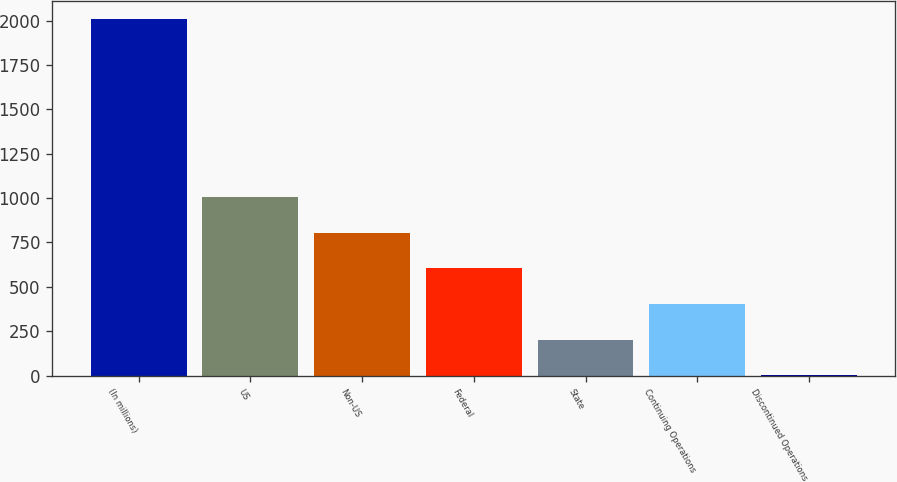<chart> <loc_0><loc_0><loc_500><loc_500><bar_chart><fcel>(In millions)<fcel>US<fcel>Non-US<fcel>Federal<fcel>State<fcel>Continuing Operations<fcel>Discontinued Operations<nl><fcel>2010<fcel>1005.75<fcel>804.9<fcel>604.05<fcel>202.35<fcel>403.2<fcel>1.5<nl></chart> 